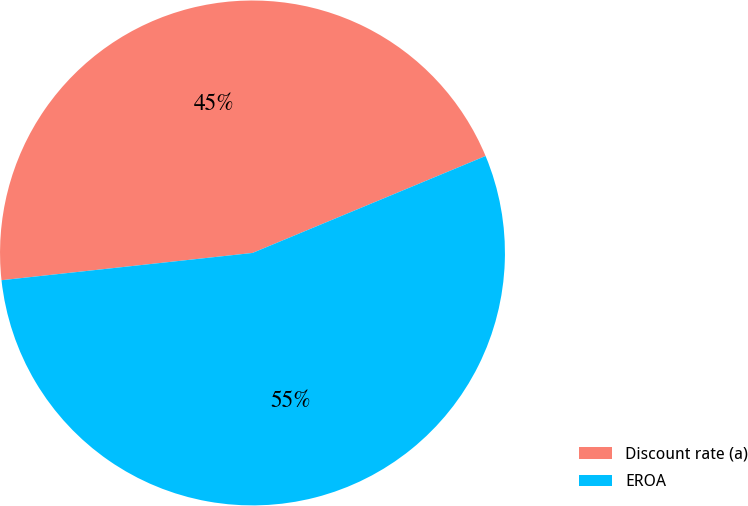Convert chart. <chart><loc_0><loc_0><loc_500><loc_500><pie_chart><fcel>Discount rate (a)<fcel>EROA<nl><fcel>45.45%<fcel>54.55%<nl></chart> 